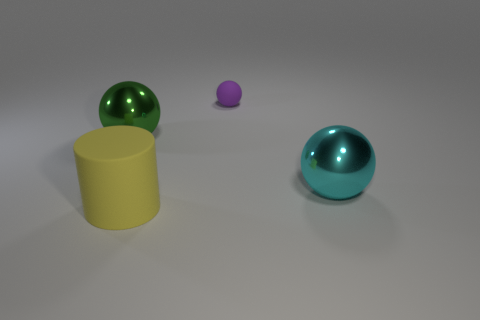Are there any other things that have the same size as the purple sphere?
Your answer should be very brief. No. What material is the sphere that is behind the large metal sphere that is behind the large cyan metallic object?
Offer a very short reply. Rubber. What color is the other large metallic thing that is the same shape as the large cyan metal object?
Keep it short and to the point. Green. How many large cylinders have the same color as the tiny sphere?
Give a very brief answer. 0. There is a large sphere to the right of the small thing; is there a ball left of it?
Offer a very short reply. Yes. What number of big things are on the left side of the small rubber ball and behind the large yellow matte cylinder?
Your answer should be compact. 1. How many cyan things have the same material as the big green sphere?
Your response must be concise. 1. There is a rubber object in front of the big sphere that is right of the small purple rubber ball; how big is it?
Provide a short and direct response. Large. Is there a cyan shiny object that has the same shape as the small purple matte object?
Give a very brief answer. Yes. Is the size of the shiny object that is on the left side of the large cyan thing the same as the matte thing behind the large cyan shiny object?
Provide a short and direct response. No. 